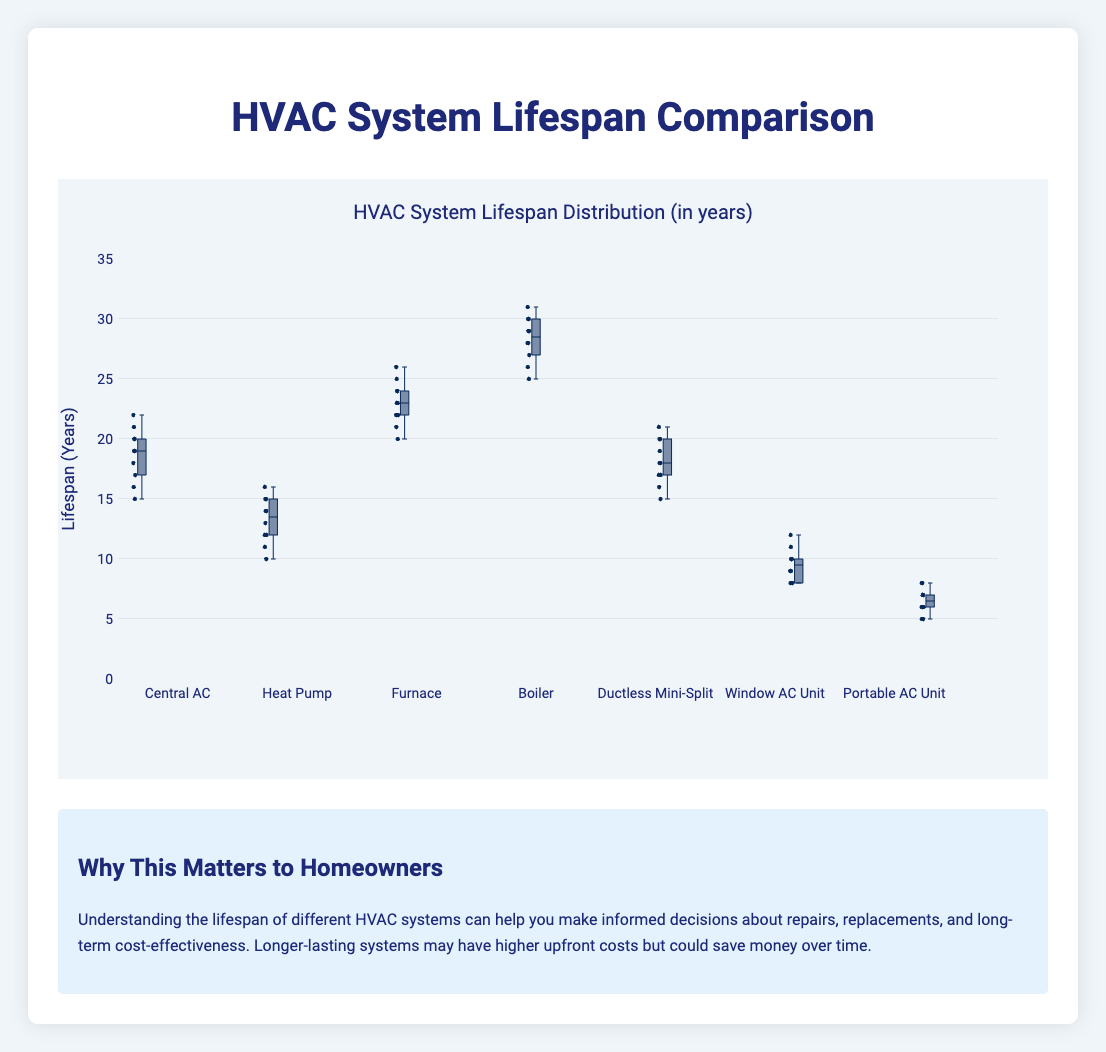Which HVAC system type has the longest average lifespan? First, observe the boxes' central lines which represent the median values. Look for the type with the highest median. Here, the Boiler has the highest median value which indicates the longest average lifespan.
Answer: Boiler Which type of HVAC unit has the shortest minimum lifespan? Identify the bottom whisker of each box. The shortest minimum lifespan is represented by the lowest bottom whisker, which belongs to the Portable AC Unit.
Answer: Portable AC Unit What is the range of lifespans for Central AC units? The range is the difference between the maximum and minimum values. For Central AC units, the maximum value is 22 and the minimum value is 15. So the range is 22 - 15 = 7 years.
Answer: 7 years Compare the median lifespan of Furnaces and Heat Pumps. Which has a higher median? Compare the central lines of the boxes for Furnaces and Heat Pumps. The Furnace has a higher median compared to Heat Pump.
Answer: Furnace For the Window AC Unit, what is the interquartile range (IQR) of its lifespan? The IQR is the difference between the third quartile (Q3) and the first quartile (Q1). From the plot, for Window AC Units: Q3 is roughly 10.5 and Q1 is about 8.5. So, the IQR = 10.5 - 8.5 = 2 years.
Answer: 2 years Which HVAC unit type has the widest spread in lifespans? Look at the length of the boxes and the whiskers to identify the widest spread. The Boiler has the widest spread in lifespans.
Answer: Boiler Does any HVAC type have outliers? To find outliers, look for data points that lie outside the whiskers. In this box plot, there are no dots outside the whiskers, indicating no outliers for any HVAC type.
Answer: No What's the median lifespan of a Ductless Mini-Split unit? The median is indicated by the central line inside the box for Ductless Mini-Split, which appears to be around 18 years.
Answer: 18 years Which HVAC type has the most consistent (least variable) lifespan? Consistency is indicated by the narrowest box and the shortest whiskers. The Portable AC Unit shows the most consistent lifespan.
Answer: Portable AC Unit 